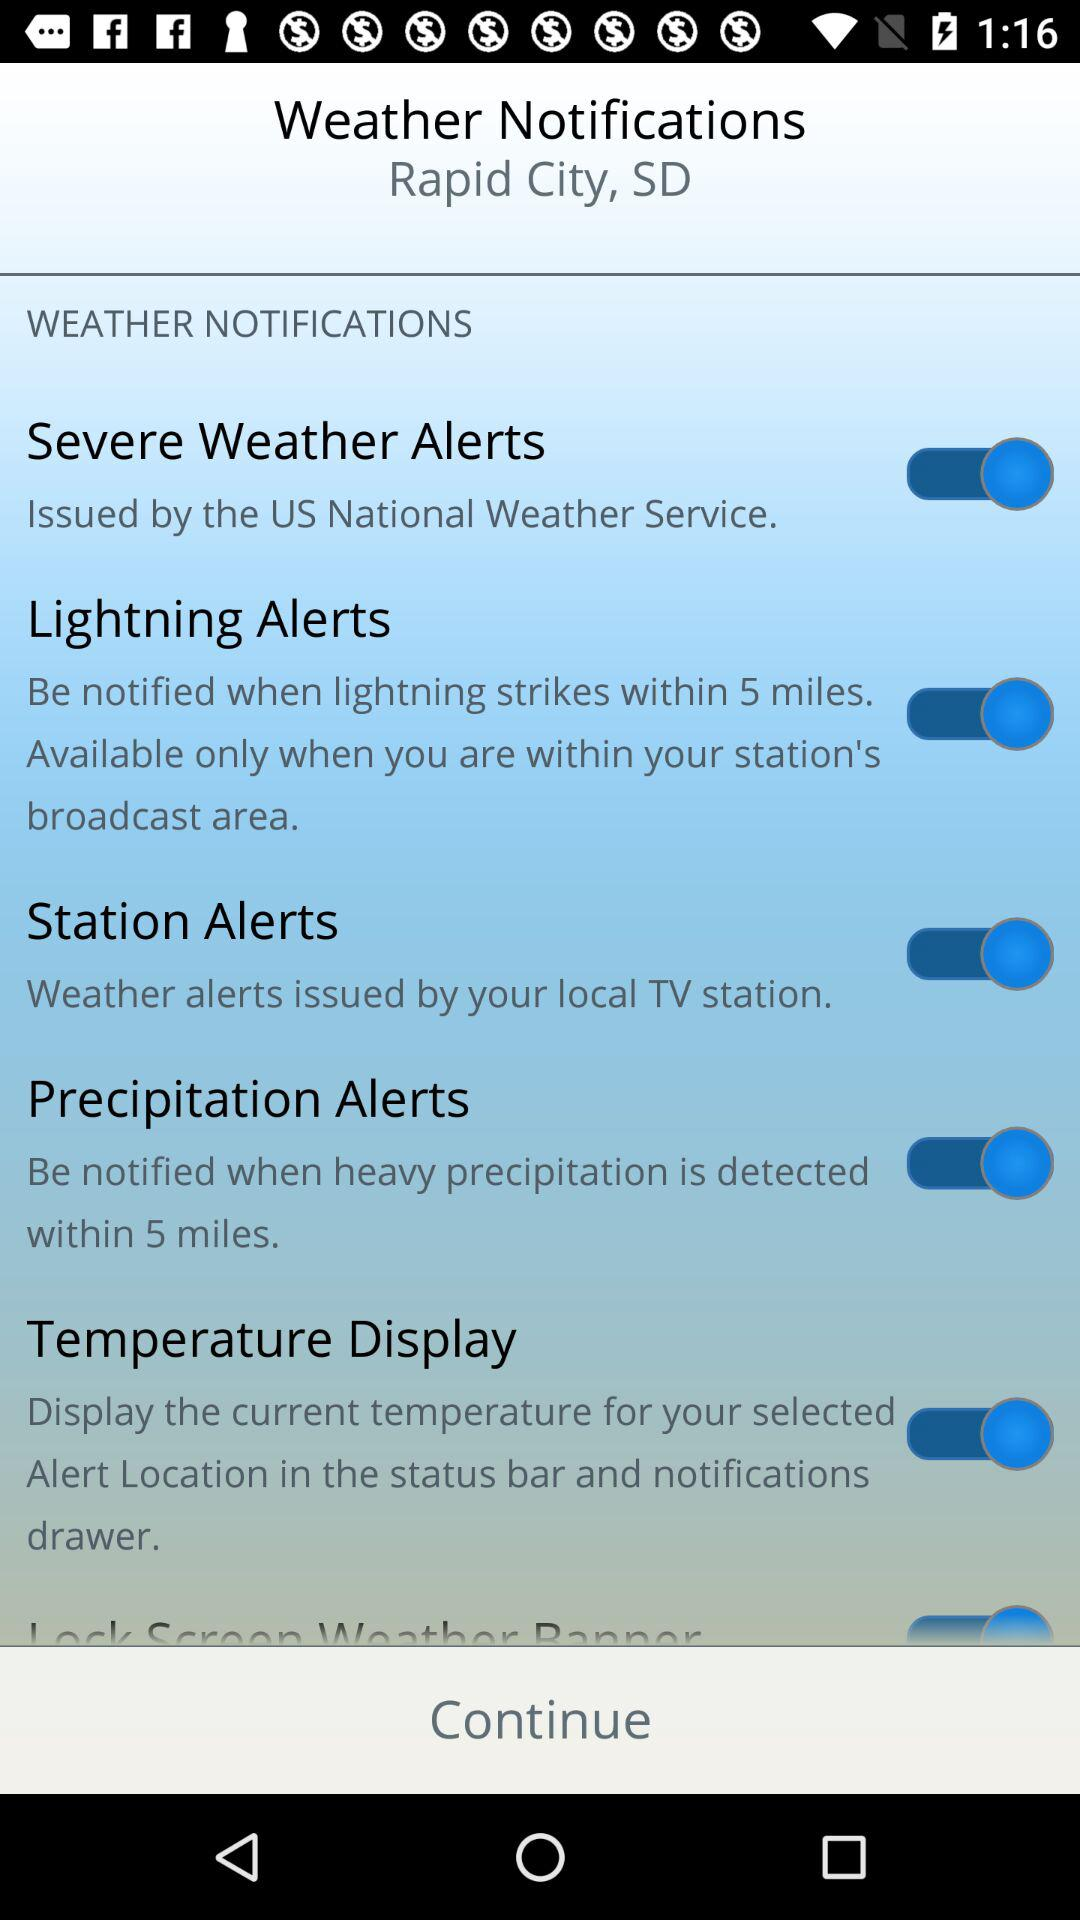What city is the weather notification for? The weather notification is for Rapid City, SD. 